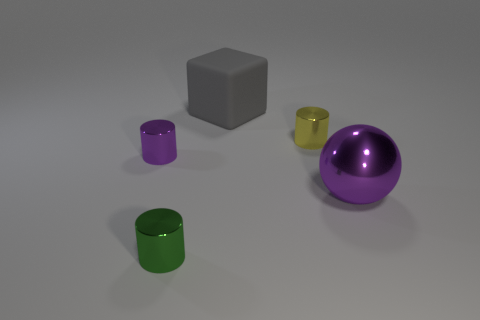What number of small green things are in front of the small thing on the left side of the cylinder in front of the ball? 1 